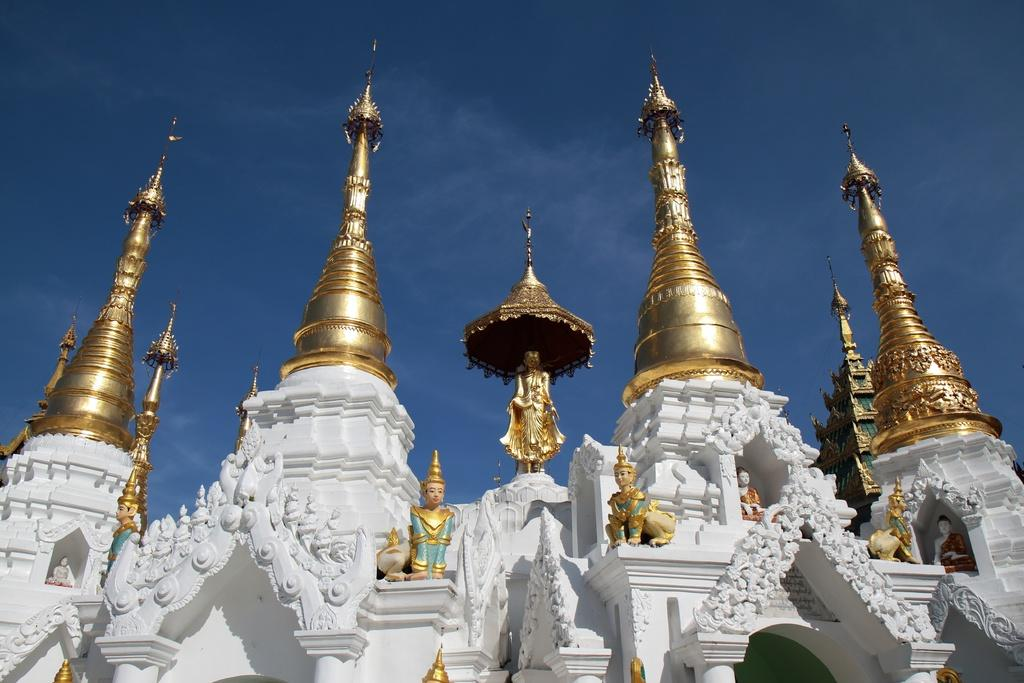What type of building is depicted in the image? There is a temple in the image. What can be seen on the walls of the temple? There are sculptures on the walls of the temple. What is visible in the background of the image? The sky is visible in the image. How many ducks are swimming in the jelly on the temple's roof in the image? There are no ducks or jelly present in the image, and the temple does not have a roof. 